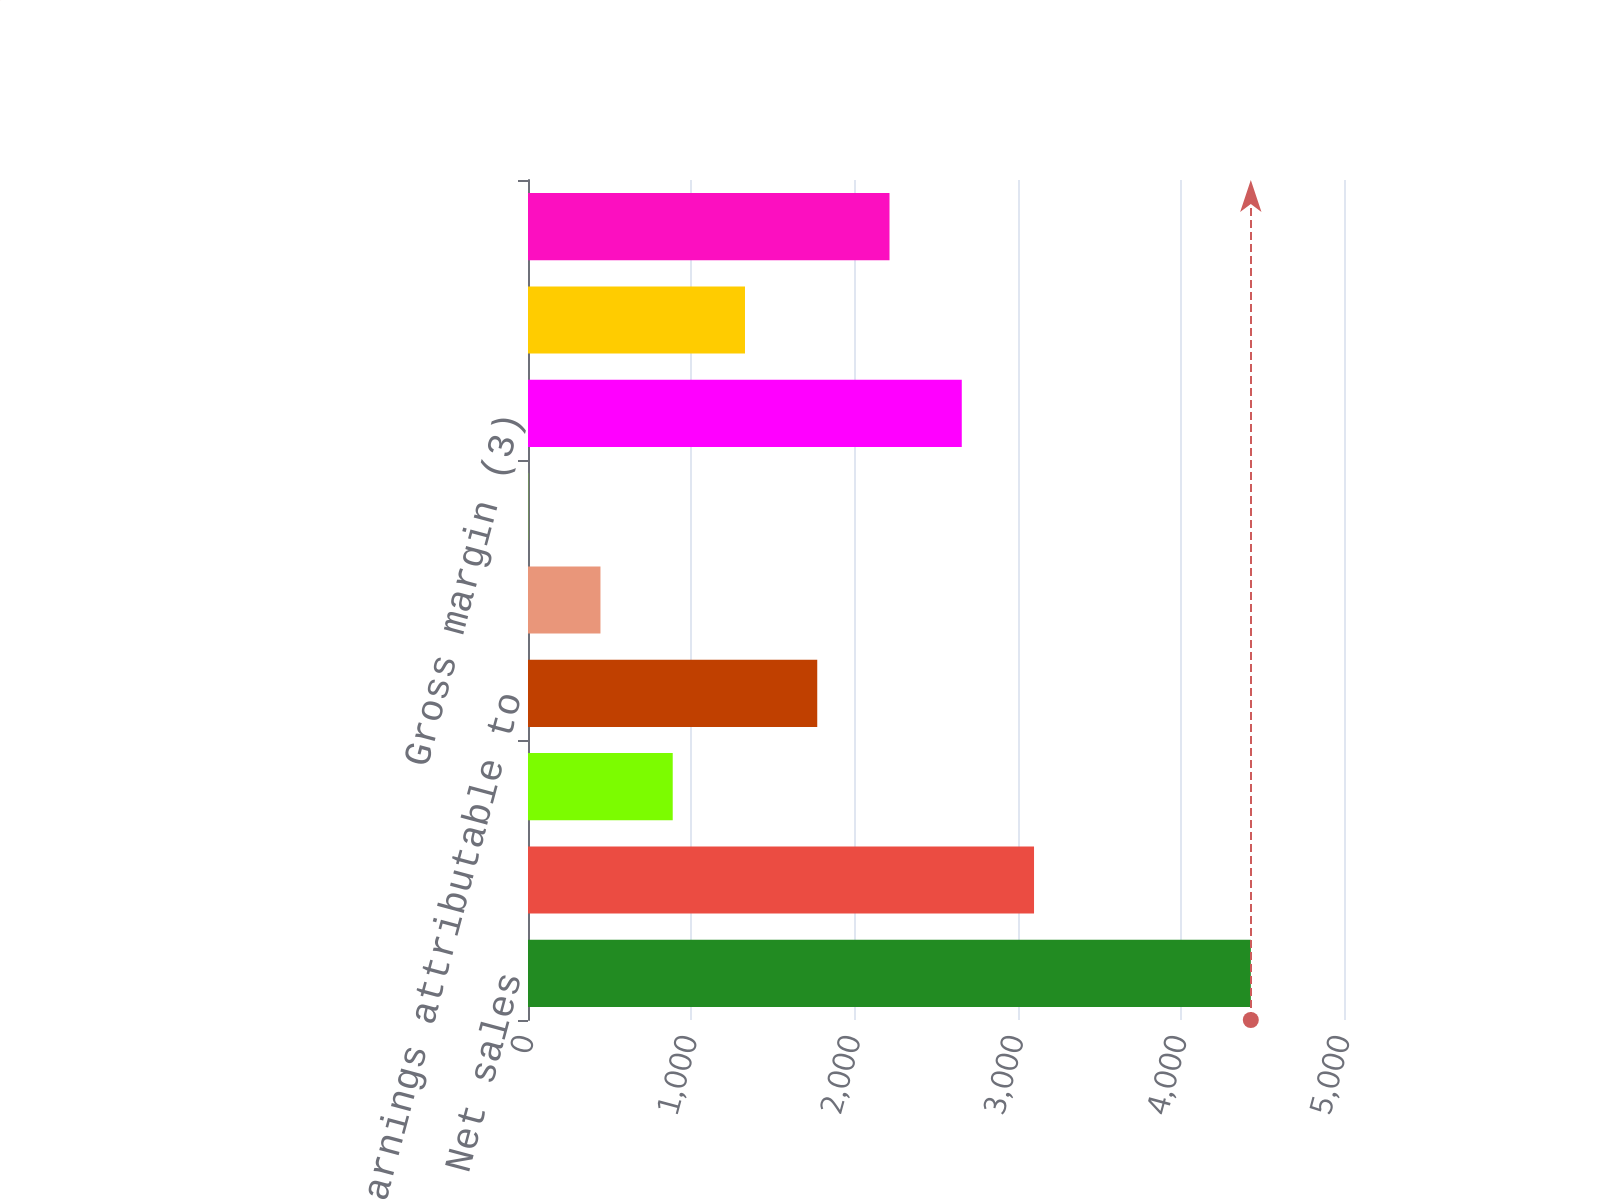<chart> <loc_0><loc_0><loc_500><loc_500><bar_chart><fcel>Net sales<fcel>Gross margin<fcel>Unrealized gains on natural<fcel>Net earnings attributable to<fcel>Basic (2)<fcel>Diluted (2)<fcel>Gross margin (3)<fcel>Unrealized (losses) gains on<fcel>Net (loss) earnings<nl><fcel>4429<fcel>3100.7<fcel>886.8<fcel>1772.36<fcel>444.02<fcel>1.24<fcel>2657.92<fcel>1329.58<fcel>2215.14<nl></chart> 